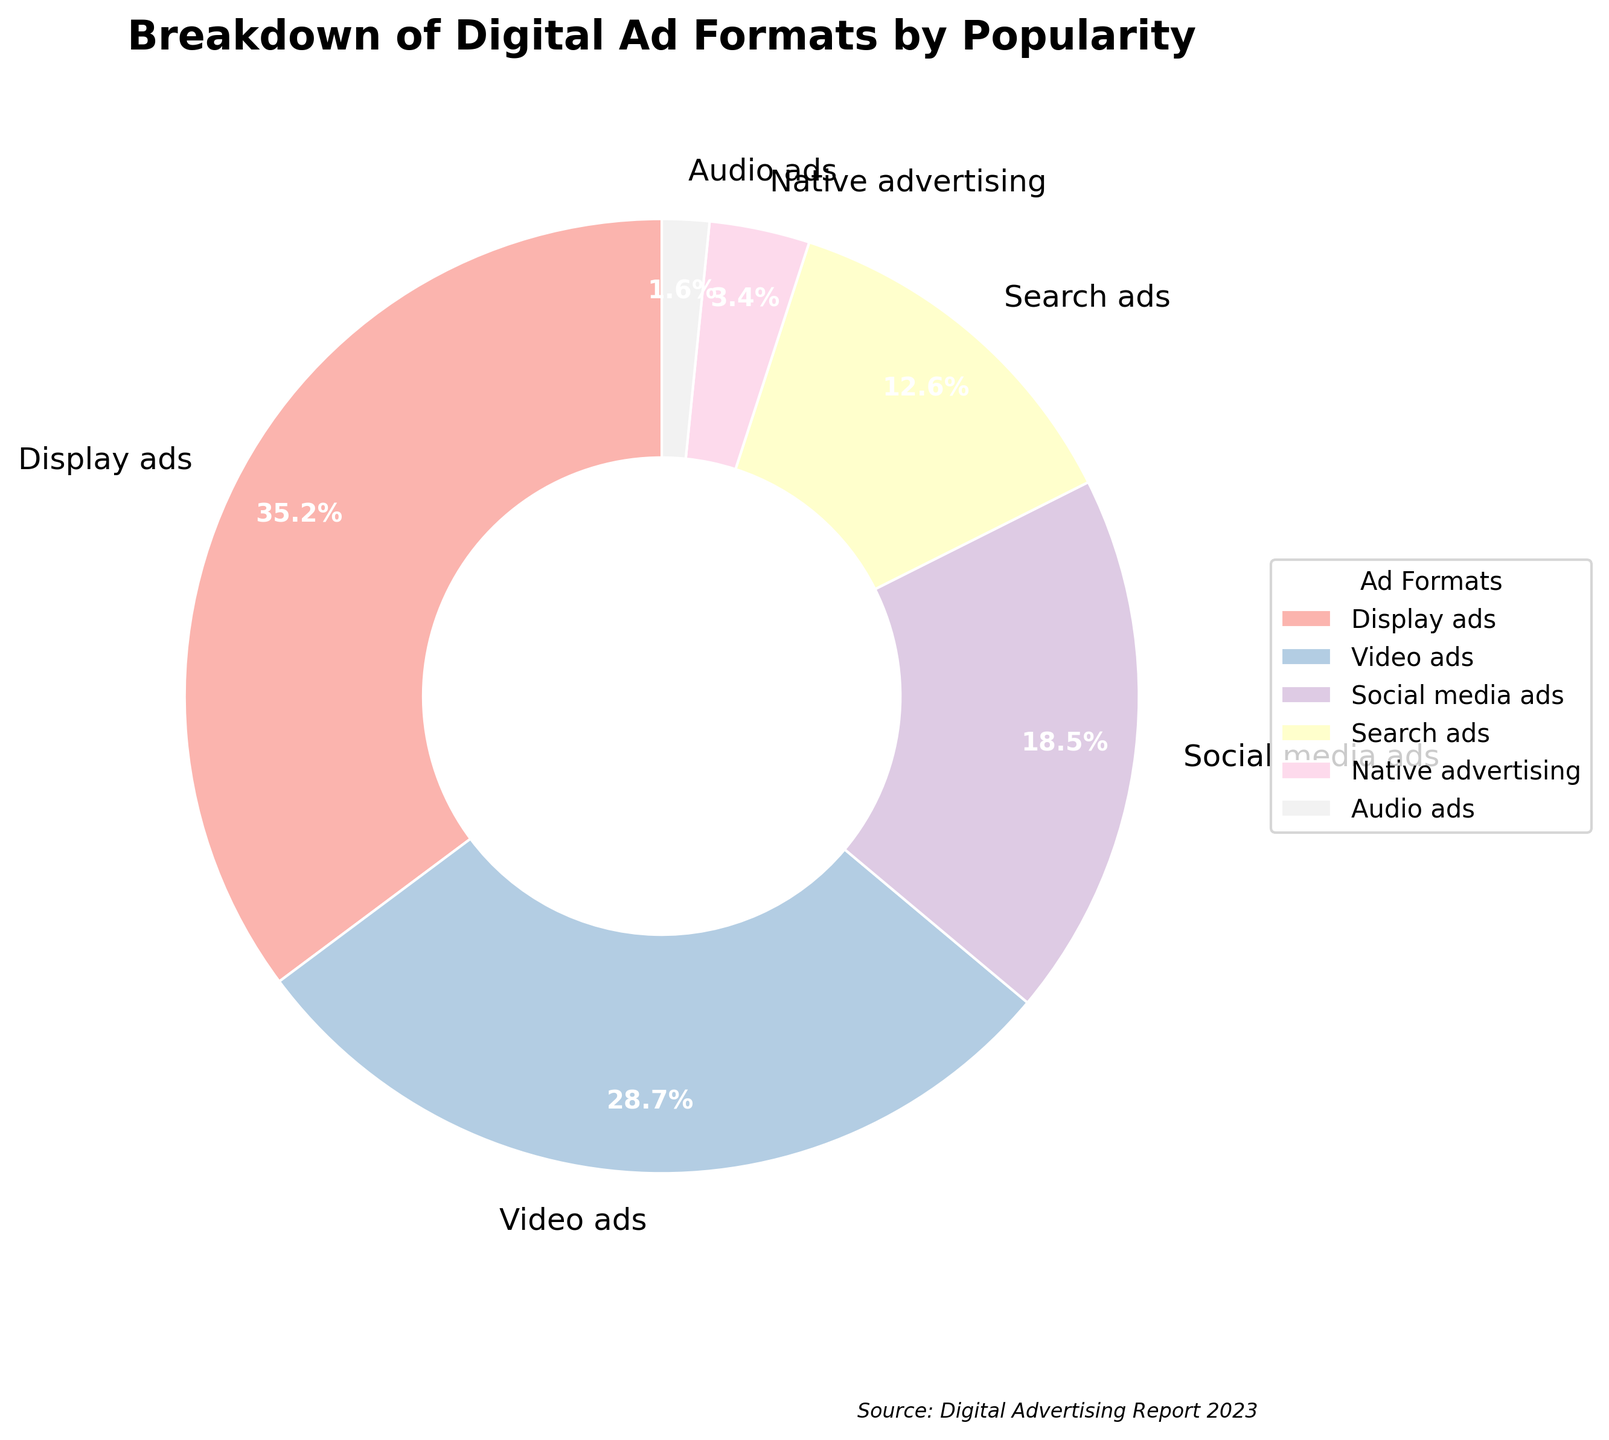What is the most popular digital ad format according to the pie chart? The pie chart shows the percentages of different ad formats, and the largest segment belongs to Display ads.
Answer: Display ads Compare the combined popularity of Video ads and Social media ads against Display ads. Which is higher? Video ads and Social media ads have percentages of 28.7% and 18.5% respectively, giving a combined total of 47.2%. Display ads alone have 35.2%. Since 47.2% is greater than 35.2%, Video ads + Social media ads is higher.
Answer: Video ads + Social media ads Which digital ad format has the smallest percentage in the pie chart? The smallest segment in the pie chart, representing the ad format with the lowest percentage, is Audio ads with 1.6%.
Answer: Audio ads By what percentage do Display ads exceed Search ads? Display ads have 35.2% and Search ads have 12.6%. Subtracting these, 35.2% - 12.6% equals 22.6%. Display ads exceed Search ads by 22.6%.
Answer: 22.6% What is the combined percentage of Native advertising and Audio ads? Native advertising contributes 3.4% and Audio ads contribute 1.6%. Adding these together, 3.4% + 1.6% equals 5.0%.
Answer: 5.0% Which is more popular, Social media ads or Search ads, and by how much? Social media ads have 18.5% and Search ads have 12.6%. Subtracting these, 18.5% - 12.6% equals 5.9%. Social media ads are more popular by 5.9%.
Answer: Social media ads by 5.9% Rank all the digital ad formats from most popular to least popular based on the pie chart. Display ads (35.2%), Video ads (28.7%), Social media ads (18.5%), Search ads (12.6%), Native advertising (3.4%), Audio ads (1.6%).
Answer: Display ads, Video ads, Social media ads, Search ads, Native advertising, Audio ads What is the total percentage difference between Display ads and Native advertising? Display ads are 35.2% and Native advertising is 3.4%. Subtracting these, 35.2% - 3.4% equals 31.8%. The total percentage difference is 31.8%.
Answer: 31.8% Calculate the average percentage of Display ads and Video ads. Display ads are 35.2% and Video ads are 28.7%. Adding these together, 35.2% + 28.7% equals 63.9%. Dividing by 2, the average is 63.9% / 2 = 31.95%.
Answer: 31.95% Which segments of the pie chart are colored in the lightest shades, and what are their associated ad formats? The lightest shades in a pie chart often represent the smallest segments, which are Native advertising (3.4%) and Audio ads (1.6%).
Answer: Native advertising and Audio ads 